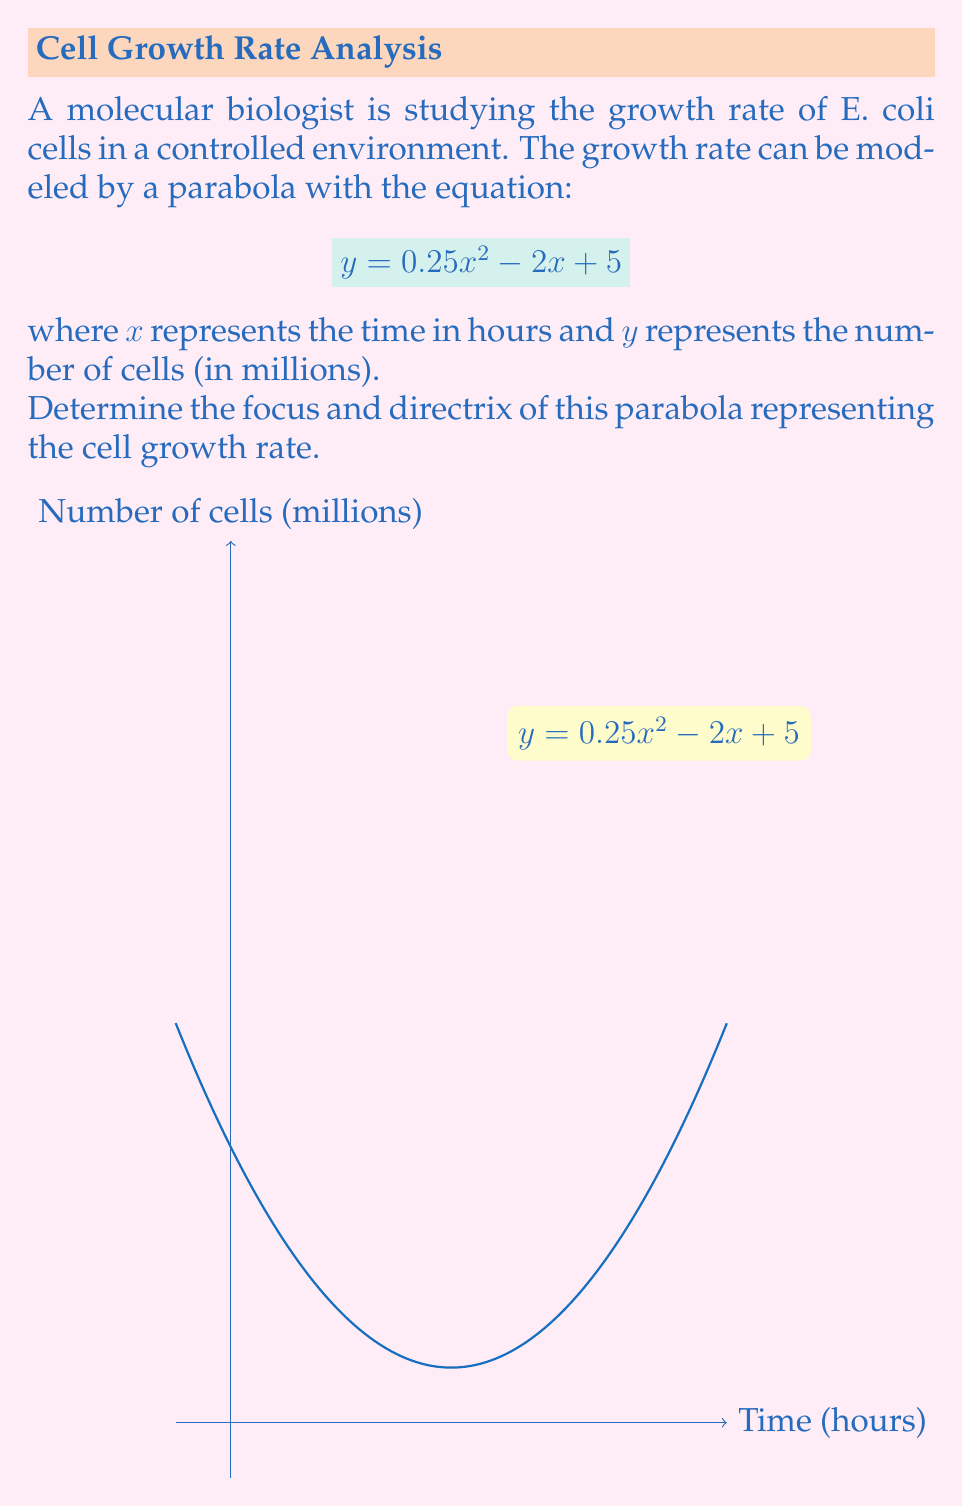Provide a solution to this math problem. Let's approach this step-by-step:

1) The general form of a parabola is $y = ax^2 + bx + c$. In this case:
   $a = 0.25$, $b = -2$, and $c = 5$

2) For a parabola in the form $y = ax^2 + bx + c$:
   - The vertex is at $(-\frac{b}{2a}, f(-\frac{b}{2a}))$
   - The focus is $(-\frac{b}{2a}, f(-\frac{b}{2a}) + \frac{1}{4a})$
   - The directrix is the line $y = f(-\frac{b}{2a}) - \frac{1}{4a}$

3) Let's calculate the x-coordinate of the vertex:
   $x = -\frac{b}{2a} = -\frac{-2}{2(0.25)} = 4$

4) Now, let's find the y-coordinate of the vertex:
   $y = f(4) = 0.25(4)^2 - 2(4) + 5 = 4 - 8 + 5 = 1$

   So, the vertex is at (4, 1)

5) For the focus:
   $y$-coordinate = $1 + \frac{1}{4(0.25)} = 1 + 1 = 2$
   The focus is at (4, 2)

6) For the directrix:
   $y = 1 - \frac{1}{4(0.25)} = 1 - 1 = 0$
   The directrix is the line $y = 0$
Answer: Focus: (4, 2); Directrix: $y = 0$ 